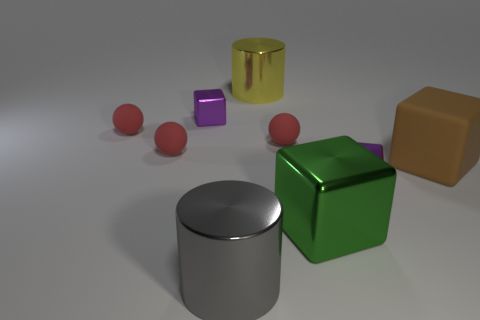Subtract all purple cubes. How many were subtracted if there are1purple cubes left? 1 Subtract all cylinders. How many objects are left? 7 Subtract 3 spheres. How many spheres are left? 0 Subtract all cyan spheres. Subtract all green cylinders. How many spheres are left? 3 Subtract all yellow cubes. How many blue balls are left? 0 Subtract all small purple things. Subtract all big green metallic things. How many objects are left? 6 Add 5 yellow metal cylinders. How many yellow metal cylinders are left? 6 Add 4 large matte things. How many large matte things exist? 5 Subtract all gray cylinders. How many cylinders are left? 1 Subtract all metal cubes. How many cubes are left? 1 